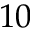<formula> <loc_0><loc_0><loc_500><loc_500>1 0</formula> 